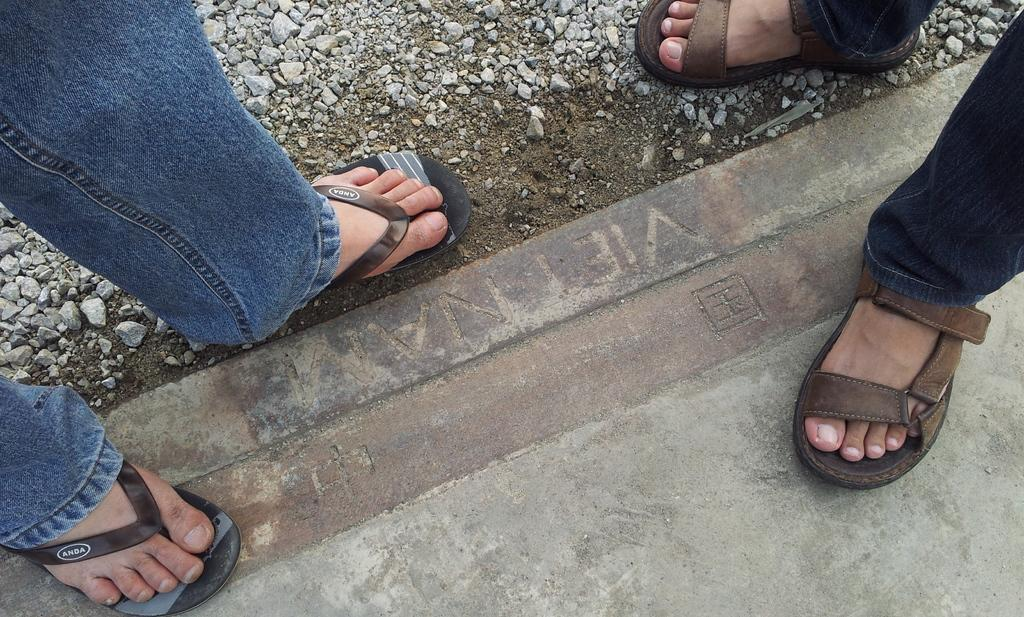What is visible in the image? There are two people's legs and stones on a platform in the image. Can you describe the platform in the image? The platform has stones on it. What type of force is being applied to the rail in the image? There is no rail present in the image. What time is indicated on the watch in the image? There is no watch present in the image. 